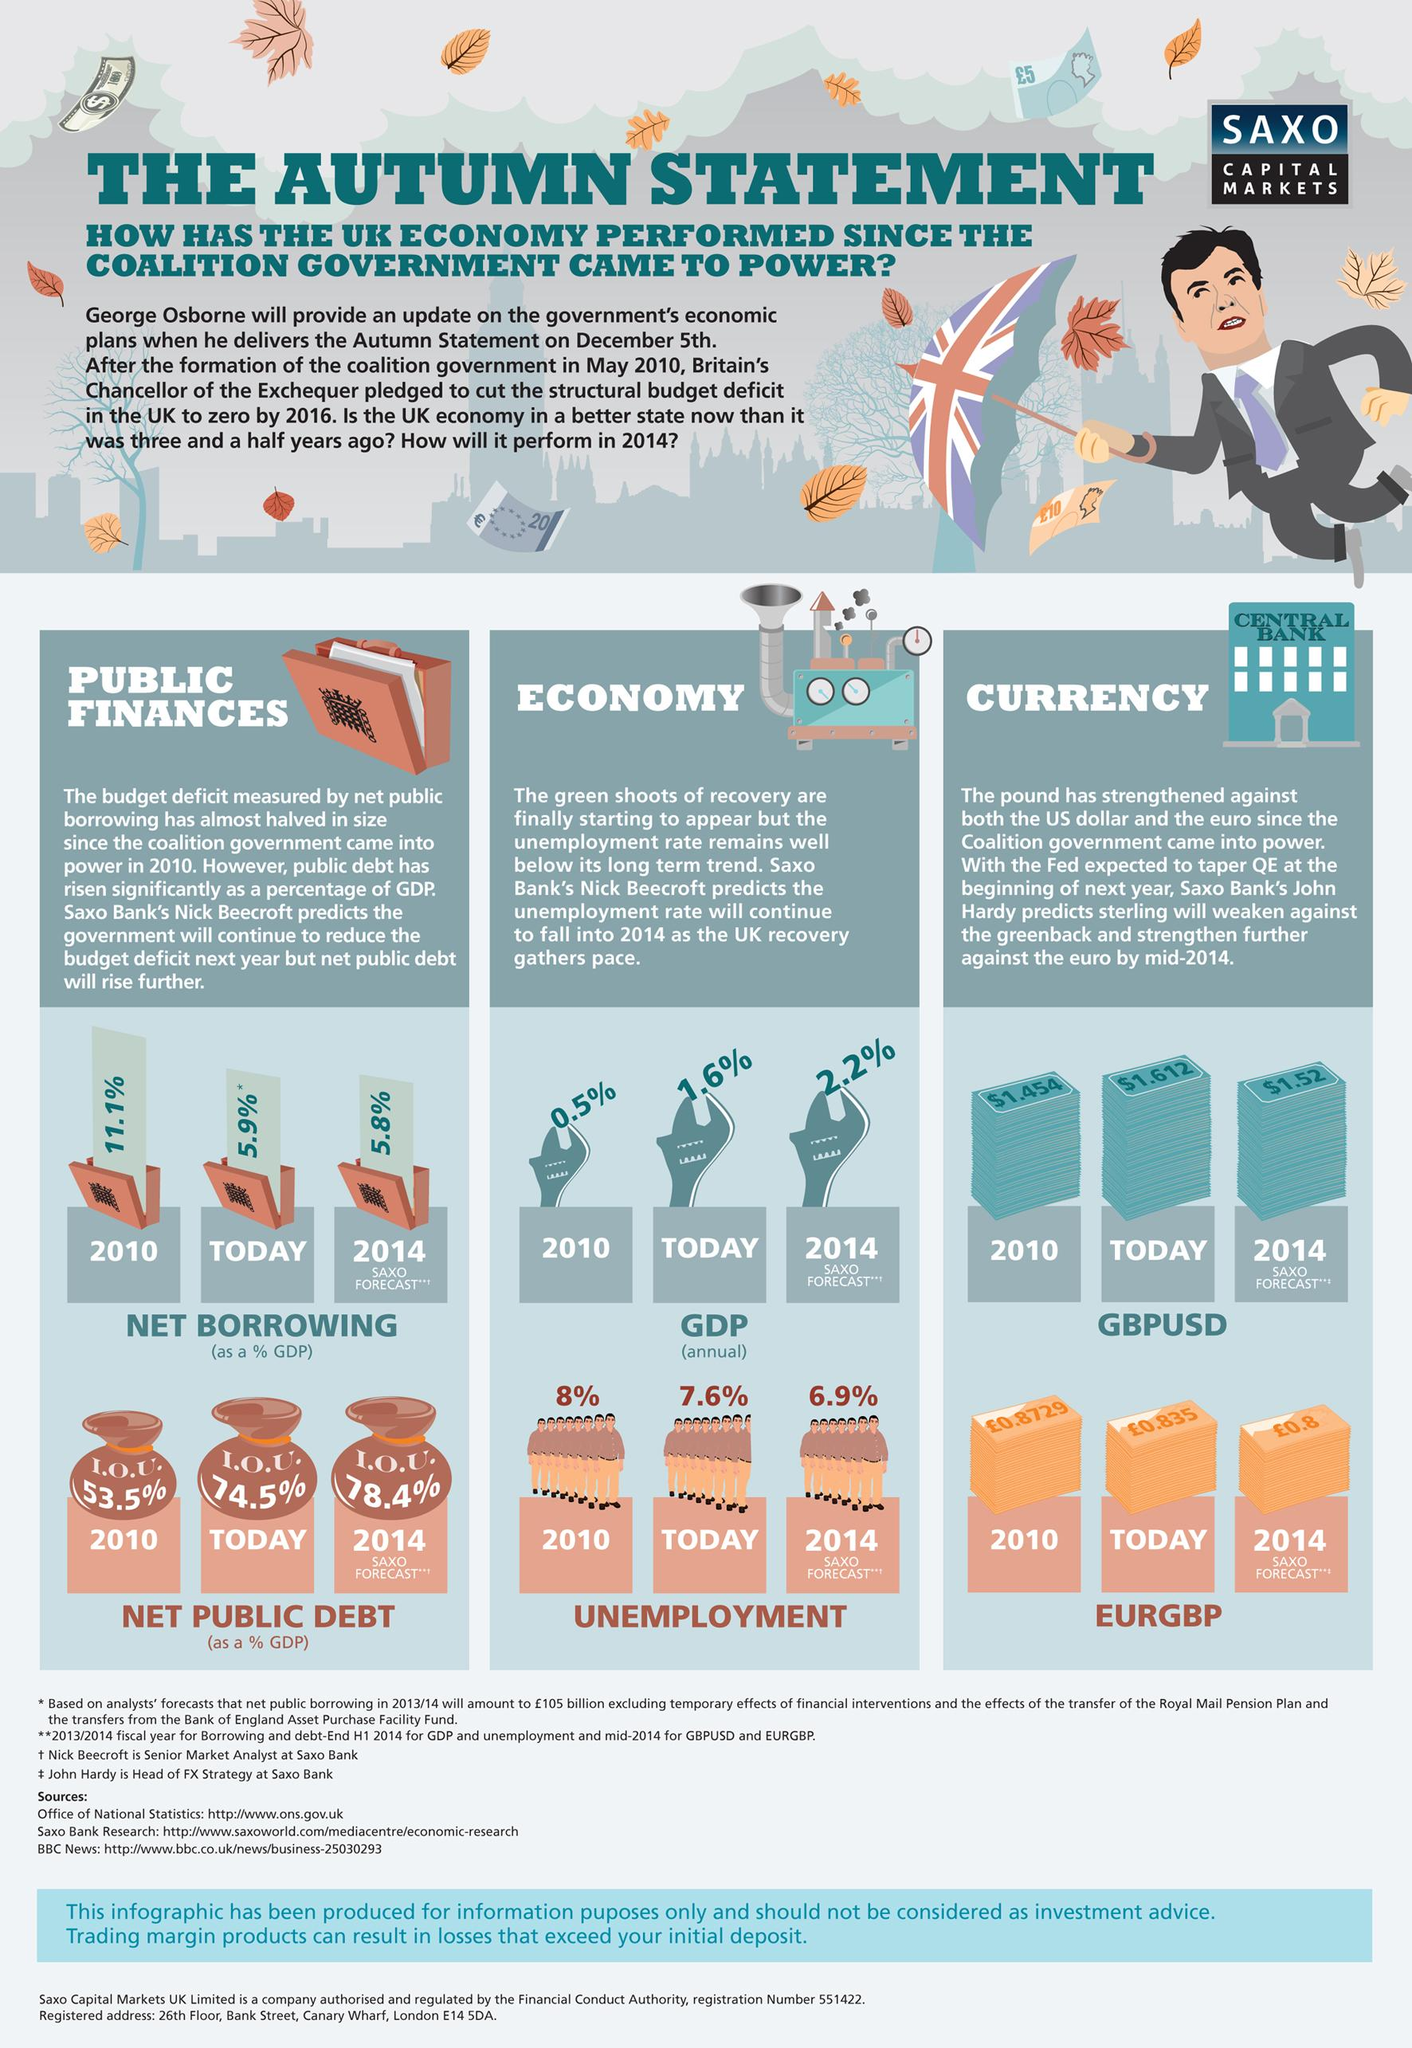Identify some key points in this picture. The currency acronyms discussed are GBPUSD and EURGBP. The building in the image has the written text "Central Bank" beside the currency, which suggests that it is a depiction of a central bank. The net borrowing is expected to decrease in the future. The value of the pound in 2010 was approximately 0.8729. Public finances are comprised of two main points: net borrowing and net public debt. 